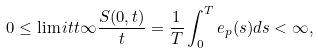<formula> <loc_0><loc_0><loc_500><loc_500>0 \leq \lim i t { t } { \infty } \frac { S ( 0 , t ) } { t } = \frac { 1 } { T } \int _ { 0 } ^ { T } e _ { p } ( s ) d s < \infty ,</formula> 